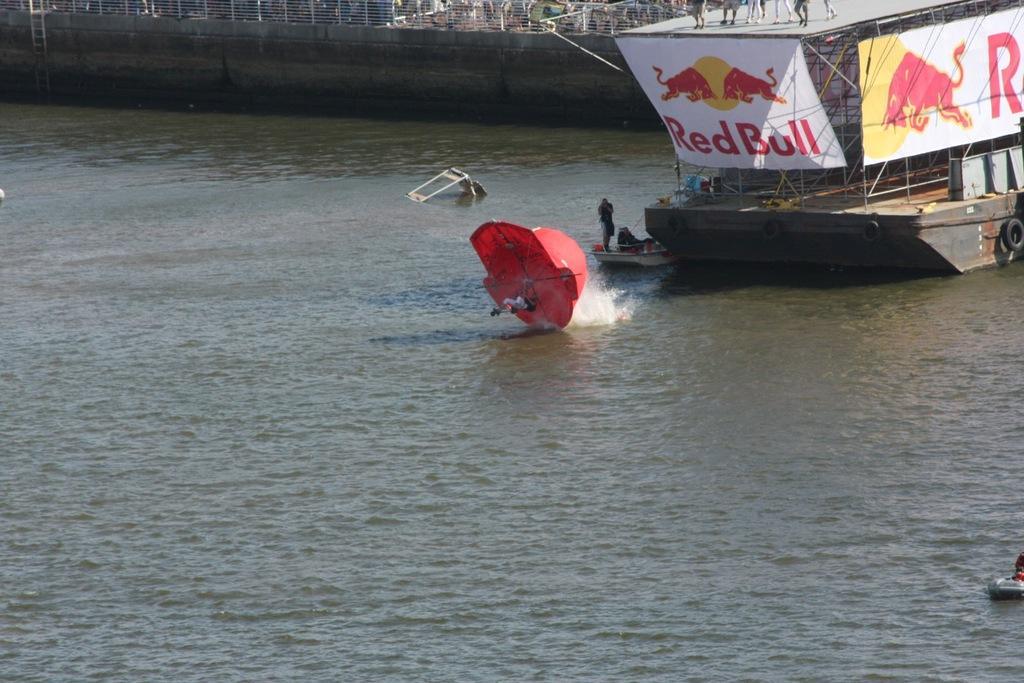Could you give a brief overview of what you see in this image? In this image I can see the boat on the water and I can also see a red color object on the water, background I can see few persons standing, few banners attached to the boat and the banners are in white and red color. 